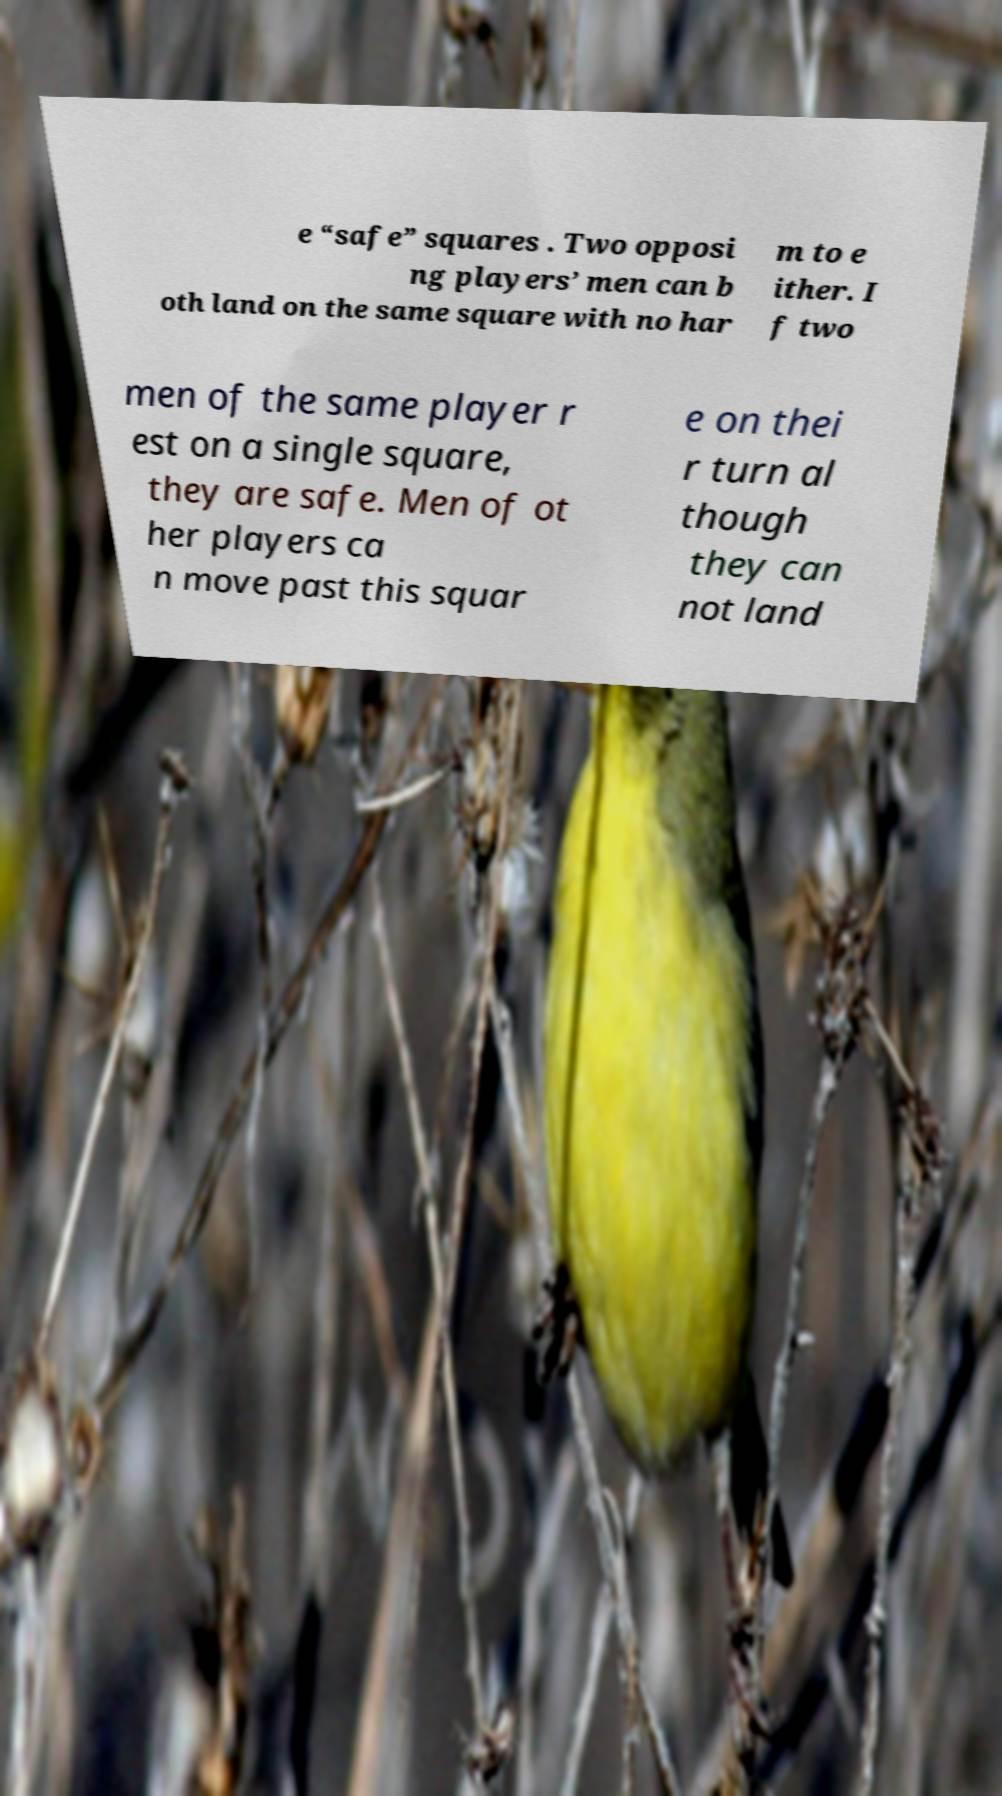What messages or text are displayed in this image? I need them in a readable, typed format. e “safe” squares . Two opposi ng players’ men can b oth land on the same square with no har m to e ither. I f two men of the same player r est on a single square, they are safe. Men of ot her players ca n move past this squar e on thei r turn al though they can not land 